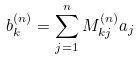Convert formula to latex. <formula><loc_0><loc_0><loc_500><loc_500>b _ { k } ^ { ( n ) } = \sum _ { j = 1 } ^ { n } M _ { k j } ^ { ( n ) } a _ { j }</formula> 